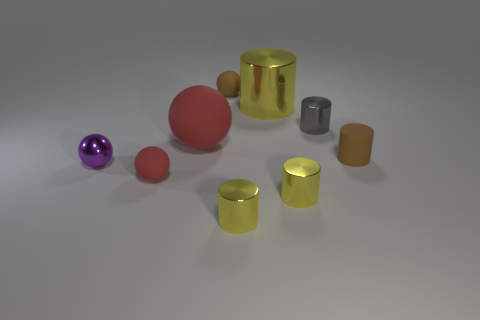What is the shape of the object that is the same color as the large rubber sphere?
Offer a terse response. Sphere. Is the number of big red matte things less than the number of big blue rubber things?
Ensure brevity in your answer.  No. What number of large things are brown cylinders or yellow metallic cylinders?
Your answer should be compact. 1. What number of things are to the left of the gray shiny thing and to the right of the big matte object?
Offer a very short reply. 4. Is the number of big rubber spheres greater than the number of brown rubber things?
Your response must be concise. No. How many other objects are the same shape as the big matte thing?
Provide a succinct answer. 3. Do the big cylinder and the tiny matte cylinder have the same color?
Give a very brief answer. No. There is a thing that is both left of the small brown ball and behind the metallic ball; what material is it made of?
Your answer should be compact. Rubber. The rubber cylinder is what size?
Your response must be concise. Small. There is a big yellow metal cylinder to the left of the brown matte thing that is in front of the gray shiny cylinder; how many tiny brown things are in front of it?
Make the answer very short. 1. 